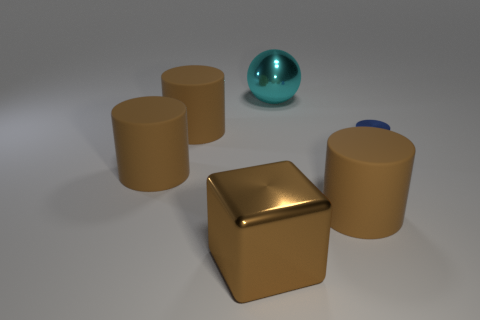Is there a cylinder of the same color as the block?
Your answer should be compact. Yes. Do the matte cylinder that is to the right of the shiny sphere and the big brown shiny thing have the same size?
Your answer should be compact. Yes. What color is the metal block?
Your answer should be very brief. Brown. What color is the large metal object behind the matte cylinder to the right of the large cyan thing?
Your answer should be compact. Cyan. Are there any other brown cylinders made of the same material as the small cylinder?
Ensure brevity in your answer.  No. There is a big object in front of the brown thing that is to the right of the brown metallic cube; what is it made of?
Your response must be concise. Metal. How many other cyan metal objects have the same shape as the large cyan metallic thing?
Your response must be concise. 0. What is the shape of the big cyan thing?
Give a very brief answer. Sphere. Are there fewer metallic spheres than tiny green matte balls?
Make the answer very short. No. Are there any other things that are the same size as the metallic cylinder?
Your answer should be compact. No. 